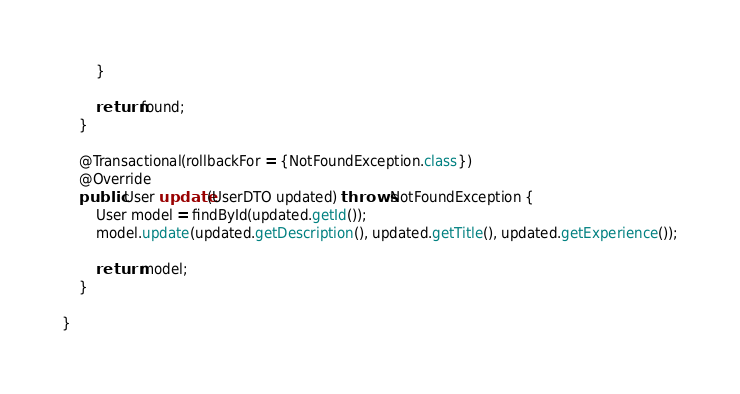<code> <loc_0><loc_0><loc_500><loc_500><_Java_>        }

        return found;
    }

    @Transactional(rollbackFor = {NotFoundException.class})
    @Override
    public User update(UserDTO updated) throws NotFoundException {
    	User model = findById(updated.getId());
        model.update(updated.getDescription(), updated.getTitle(), updated.getExperience());

        return model;
    }

}
</code> 